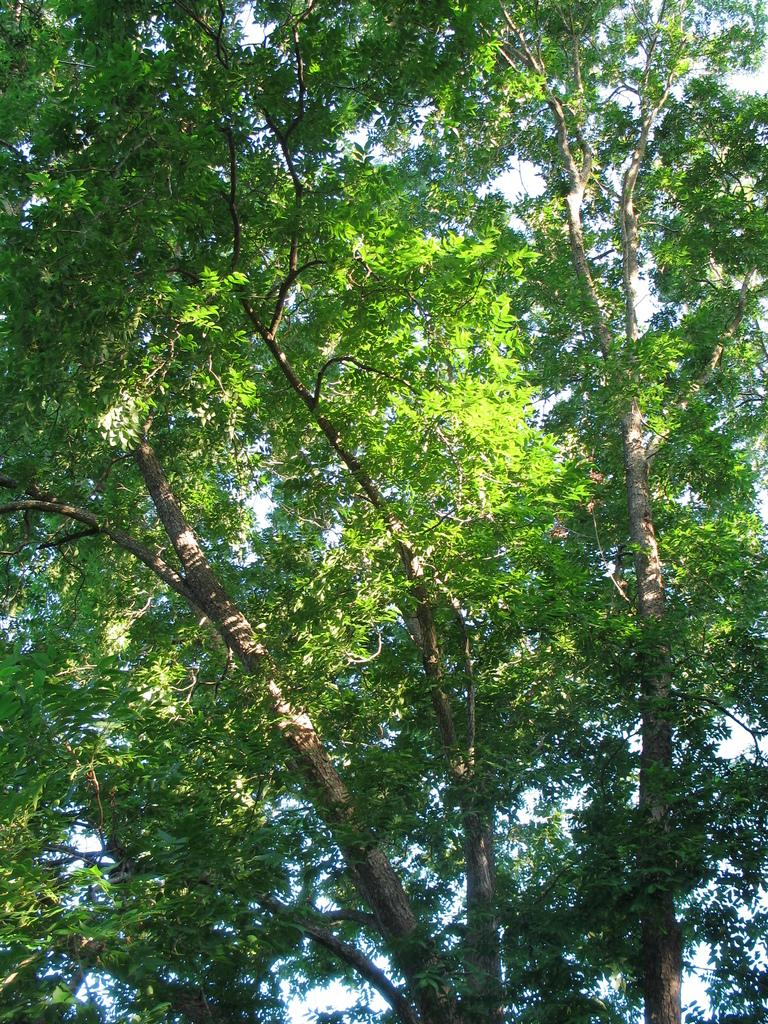What type of vegetation can be seen in the image? There are trees in the image. What part of the natural environment is visible in the image? The sky is visible in the image. What type of vase is used to sort the treatment in the image? There is no vase, sorting, or treatment present in the image. 